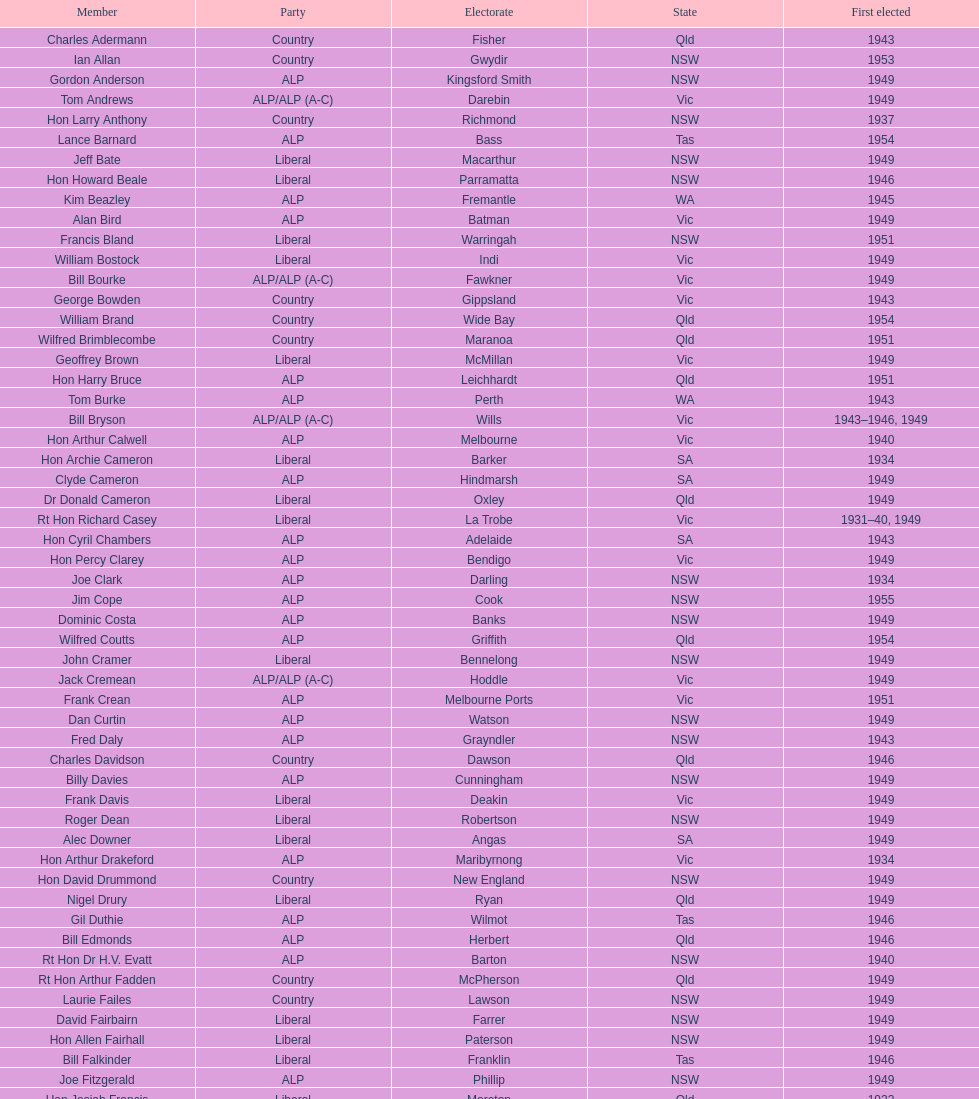When was joe clark's maiden election? 1934. Could you parse the entire table? {'header': ['Member', 'Party', 'Electorate', 'State', 'First elected'], 'rows': [['Charles Adermann', 'Country', 'Fisher', 'Qld', '1943'], ['Ian Allan', 'Country', 'Gwydir', 'NSW', '1953'], ['Gordon Anderson', 'ALP', 'Kingsford Smith', 'NSW', '1949'], ['Tom Andrews', 'ALP/ALP (A-C)', 'Darebin', 'Vic', '1949'], ['Hon Larry Anthony', 'Country', 'Richmond', 'NSW', '1937'], ['Lance Barnard', 'ALP', 'Bass', 'Tas', '1954'], ['Jeff Bate', 'Liberal', 'Macarthur', 'NSW', '1949'], ['Hon Howard Beale', 'Liberal', 'Parramatta', 'NSW', '1946'], ['Kim Beazley', 'ALP', 'Fremantle', 'WA', '1945'], ['Alan Bird', 'ALP', 'Batman', 'Vic', '1949'], ['Francis Bland', 'Liberal', 'Warringah', 'NSW', '1951'], ['William Bostock', 'Liberal', 'Indi', 'Vic', '1949'], ['Bill Bourke', 'ALP/ALP (A-C)', 'Fawkner', 'Vic', '1949'], ['George Bowden', 'Country', 'Gippsland', 'Vic', '1943'], ['William Brand', 'Country', 'Wide Bay', 'Qld', '1954'], ['Wilfred Brimblecombe', 'Country', 'Maranoa', 'Qld', '1951'], ['Geoffrey Brown', 'Liberal', 'McMillan', 'Vic', '1949'], ['Hon Harry Bruce', 'ALP', 'Leichhardt', 'Qld', '1951'], ['Tom Burke', 'ALP', 'Perth', 'WA', '1943'], ['Bill Bryson', 'ALP/ALP (A-C)', 'Wills', 'Vic', '1943–1946, 1949'], ['Hon Arthur Calwell', 'ALP', 'Melbourne', 'Vic', '1940'], ['Hon Archie Cameron', 'Liberal', 'Barker', 'SA', '1934'], ['Clyde Cameron', 'ALP', 'Hindmarsh', 'SA', '1949'], ['Dr Donald Cameron', 'Liberal', 'Oxley', 'Qld', '1949'], ['Rt Hon Richard Casey', 'Liberal', 'La Trobe', 'Vic', '1931–40, 1949'], ['Hon Cyril Chambers', 'ALP', 'Adelaide', 'SA', '1943'], ['Hon Percy Clarey', 'ALP', 'Bendigo', 'Vic', '1949'], ['Joe Clark', 'ALP', 'Darling', 'NSW', '1934'], ['Jim Cope', 'ALP', 'Cook', 'NSW', '1955'], ['Dominic Costa', 'ALP', 'Banks', 'NSW', '1949'], ['Wilfred Coutts', 'ALP', 'Griffith', 'Qld', '1954'], ['John Cramer', 'Liberal', 'Bennelong', 'NSW', '1949'], ['Jack Cremean', 'ALP/ALP (A-C)', 'Hoddle', 'Vic', '1949'], ['Frank Crean', 'ALP', 'Melbourne Ports', 'Vic', '1951'], ['Dan Curtin', 'ALP', 'Watson', 'NSW', '1949'], ['Fred Daly', 'ALP', 'Grayndler', 'NSW', '1943'], ['Charles Davidson', 'Country', 'Dawson', 'Qld', '1946'], ['Billy Davies', 'ALP', 'Cunningham', 'NSW', '1949'], ['Frank Davis', 'Liberal', 'Deakin', 'Vic', '1949'], ['Roger Dean', 'Liberal', 'Robertson', 'NSW', '1949'], ['Alec Downer', 'Liberal', 'Angas', 'SA', '1949'], ['Hon Arthur Drakeford', 'ALP', 'Maribyrnong', 'Vic', '1934'], ['Hon David Drummond', 'Country', 'New England', 'NSW', '1949'], ['Nigel Drury', 'Liberal', 'Ryan', 'Qld', '1949'], ['Gil Duthie', 'ALP', 'Wilmot', 'Tas', '1946'], ['Bill Edmonds', 'ALP', 'Herbert', 'Qld', '1946'], ['Rt Hon Dr H.V. Evatt', 'ALP', 'Barton', 'NSW', '1940'], ['Rt Hon Arthur Fadden', 'Country', 'McPherson', 'Qld', '1949'], ['Laurie Failes', 'Country', 'Lawson', 'NSW', '1949'], ['David Fairbairn', 'Liberal', 'Farrer', 'NSW', '1949'], ['Hon Allen Fairhall', 'Liberal', 'Paterson', 'NSW', '1949'], ['Bill Falkinder', 'Liberal', 'Franklin', 'Tas', '1946'], ['Joe Fitzgerald', 'ALP', 'Phillip', 'NSW', '1949'], ['Hon Josiah Francis', 'Liberal', 'Moreton', 'Qld', '1922'], ['Allan Fraser', 'ALP', 'Eden-Monaro', 'NSW', '1943'], ['Jim Fraser', 'ALP', 'Australian Capital Territory', 'ACT', '1951'], ['Gordon Freeth', 'Liberal', 'Forrest', 'WA', '1949'], ['Arthur Fuller', 'Country', 'Hume', 'NSW', '1943–49, 1951'], ['Pat Galvin', 'ALP', 'Kingston', 'SA', '1951'], ['Arthur Greenup', 'ALP', 'Dalley', 'NSW', '1953'], ['Charles Griffiths', 'ALP', 'Shortland', 'NSW', '1949'], ['Jo Gullett', 'Liberal', 'Henty', 'Vic', '1946'], ['Len Hamilton', 'Country', 'Canning', 'WA', '1946'], ['Rt Hon Eric Harrison', 'Liberal', 'Wentworth', 'NSW', '1931'], ['Jim Harrison', 'ALP', 'Blaxland', 'NSW', '1949'], ['Hon Paul Hasluck', 'Liberal', 'Curtin', 'WA', '1949'], ['Hon William Haworth', 'Liberal', 'Isaacs', 'Vic', '1949'], ['Leslie Haylen', 'ALP', 'Parkes', 'NSW', '1943'], ['Rt Hon Harold Holt', 'Liberal', 'Higgins', 'Vic', '1935'], ['John Howse', 'Liberal', 'Calare', 'NSW', '1946'], ['Alan Hulme', 'Liberal', 'Petrie', 'Qld', '1949'], ['William Jack', 'Liberal', 'North Sydney', 'NSW', '1949'], ['Rowley James', 'ALP', 'Hunter', 'NSW', '1928'], ['Hon Herbert Johnson', 'ALP', 'Kalgoorlie', 'WA', '1940'], ['Bob Joshua', 'ALP/ALP (A-C)', 'Ballaarat', 'ALP', '1951'], ['Percy Joske', 'Liberal', 'Balaclava', 'Vic', '1951'], ['Hon Wilfrid Kent Hughes', 'Liberal', 'Chisholm', 'Vic', '1949'], ['Stan Keon', 'ALP/ALP (A-C)', 'Yarra', 'Vic', '1949'], ['William Lawrence', 'Liberal', 'Wimmera', 'Vic', '1949'], ['Hon George Lawson', 'ALP', 'Brisbane', 'Qld', '1931'], ['Nelson Lemmon', 'ALP', 'St George', 'NSW', '1943–49, 1954'], ['Hugh Leslie', 'Liberal', 'Moore', 'Country', '1949'], ['Robert Lindsay', 'Liberal', 'Flinders', 'Vic', '1954'], ['Tony Luchetti', 'ALP', 'Macquarie', 'NSW', '1951'], ['Aubrey Luck', 'Liberal', 'Darwin', 'Tas', '1951'], ['Philip Lucock', 'Country', 'Lyne', 'NSW', '1953'], ['Dan Mackinnon', 'Liberal', 'Corangamite', 'Vic', '1949–51, 1953'], ['Hon Norman Makin', 'ALP', 'Sturt', 'SA', '1919–46, 1954'], ['Hon Philip McBride', 'Liberal', 'Wakefield', 'SA', '1931–37, 1937–43 (S), 1946'], ['Malcolm McColm', 'Liberal', 'Bowman', 'Qld', '1949'], ['Rt Hon John McEwen', 'Country', 'Murray', 'Vic', '1934'], ['John McLeay', 'Liberal', 'Boothby', 'SA', '1949'], ['Don McLeod', 'Liberal', 'Wannon', 'ALP', '1940–49, 1951'], ['Hon William McMahon', 'Liberal', 'Lowe', 'NSW', '1949'], ['Rt Hon Robert Menzies', 'Liberal', 'Kooyong', 'Vic', '1934'], ['Dan Minogue', 'ALP', 'West Sydney', 'NSW', '1949'], ['Charles Morgan', 'ALP', 'Reid', 'NSW', '1940–46, 1949'], ['Jack Mullens', 'ALP/ALP (A-C)', 'Gellibrand', 'Vic', '1949'], ['Jock Nelson', 'ALP', 'Northern Territory', 'NT', '1949'], ["William O'Connor", 'ALP', 'Martin', 'NSW', '1946'], ['Hubert Opperman', 'Liberal', 'Corio', 'Vic', '1949'], ['Hon Frederick Osborne', 'Liberal', 'Evans', 'NSW', '1949'], ['Rt Hon Sir Earle Page', 'Country', 'Cowper', 'NSW', '1919'], ['Henry Pearce', 'Liberal', 'Capricornia', 'Qld', '1949'], ['Ted Peters', 'ALP', 'Burke', 'Vic', '1949'], ['Hon Reg Pollard', 'ALP', 'Lalor', 'Vic', '1937'], ['Hon Bill Riordan', 'ALP', 'Kennedy', 'Qld', '1936'], ['Hugh Roberton', 'Country', 'Riverina', 'NSW', '1949'], ['Edgar Russell', 'ALP', 'Grey', 'SA', '1943'], ['Tom Sheehan', 'ALP', 'Cook', 'NSW', '1937'], ['Frank Stewart', 'ALP', 'Lang', 'NSW', '1953'], ['Reginald Swartz', 'Liberal', 'Darling Downs', 'Qld', '1949'], ['Albert Thompson', 'ALP', 'Port Adelaide', 'SA', '1946'], ['Frank Timson', 'Liberal', 'Higinbotham', 'Vic', '1949'], ['Hon Athol Townley', 'Liberal', 'Denison', 'Tas', '1949'], ['Winton Turnbull', 'Country', 'Mallee', 'Vic', '1946'], ['Harry Turner', 'Liberal', 'Bradfield', 'NSW', '1952'], ['Hon Eddie Ward', 'ALP', 'East Sydney', 'NSW', '1931, 1932'], ['David Oliver Watkins', 'ALP', 'Newcastle', 'NSW', '1935'], ['Harry Webb', 'ALP', 'Swan', 'WA', '1954'], ['William Wentworth', 'Liberal', 'Mackellar', 'NSW', '1949'], ['Roy Wheeler', 'Liberal', 'Mitchell', 'NSW', '1949'], ['Gough Whitlam', 'ALP', 'Werriwa', 'NSW', '1952'], ['Bruce Wight', 'Liberal', 'Lilley', 'Qld', '1949']]} 